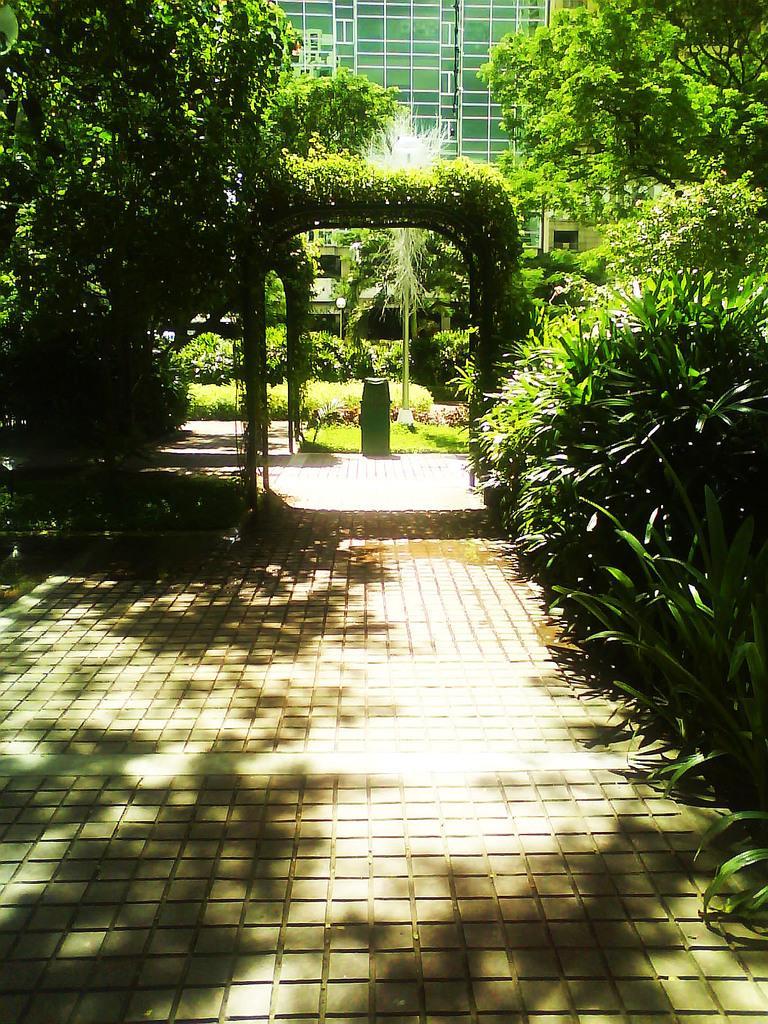How would you summarize this image in a sentence or two? These are the trees with branches and leaves. I can see an arch. This is the pathway. This looks like an object. In the background, I can see a building with the glass doors. These are the bushes. 